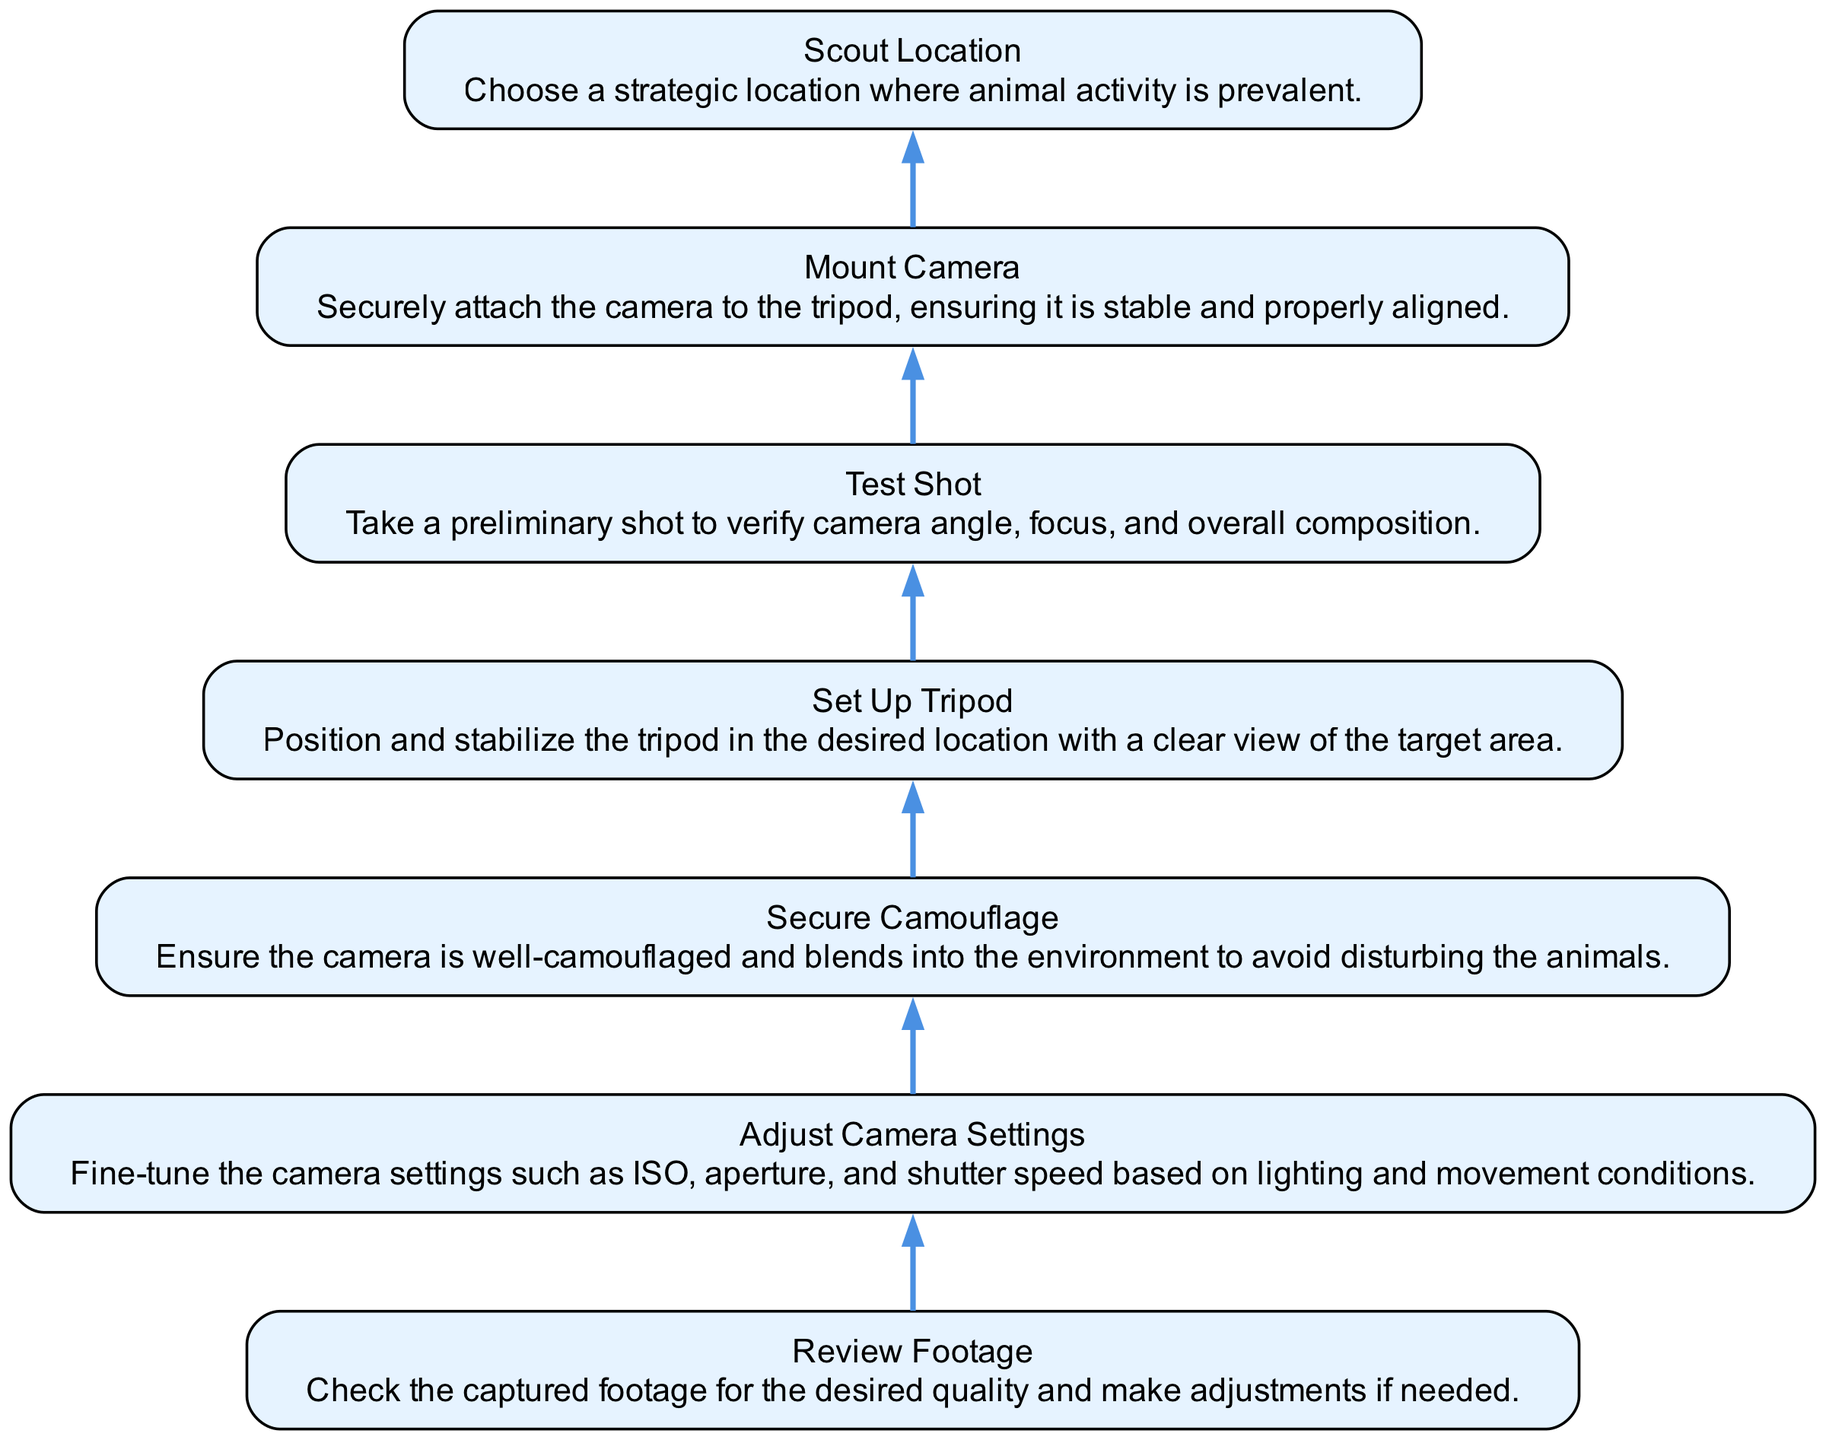What is the first step in the setup process? The diagram starts at the bottom with "Scout Location," indicating it's the first step to choose a strategic place for camera setup.
Answer: Scout Location How many nodes are present in the diagram? Counting the nodes from "Scout Location" at the bottom to "Review Footage" at the top, there are a total of 7 nodes in the flow chart.
Answer: 7 Which step comes after "Mount Camera"? By following the arrows in the diagram, "Review Footage" follows "Mount Camera," indicating that it's the next step in the setup process.
Answer: Review Footage What does "Set Up Tripod" focus on? The description provided for "Set Up Tripod" emphasizes positioning and stabilizing the tripod for a clear view, highlighting its role in setting the camera's base.
Answer: Positioning and stabilizing How is "Adjust Camera Settings" related to "Test Shot"? "Adjust Camera Settings" comes directly before "Test Shot," indicating these two actions are sequential; the camera settings need to be optimized before testing the shot.
Answer: Sequential What is the purpose of "Secure Camouflage"? The description indicates that its purpose is to ensure the camera blends into the environment to avoid disturbing animals, highlighting its role in wildlife filming.
Answer: Blend into the environment If you miss "Test Shot," what might happen? Without taking the "Test Shot," it would be difficult to verify the camera angle and focus, potentially leading to poor footage quality and missed animal behavior.
Answer: Poor footage quality What are the last two steps in the process? Moving upwards in the flow, the last two steps are "Mount Camera" and "Review Footage," showing the conclusion of the setup process after securing the camera.
Answer: Mount Camera, Review Footage 